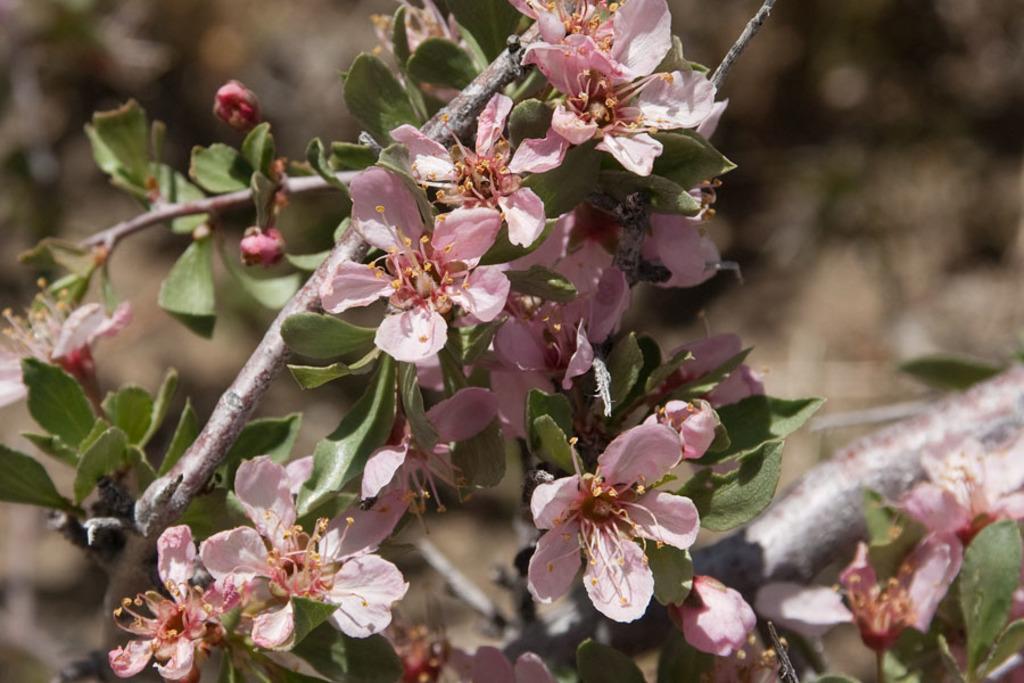Please provide a concise description of this image. In this image there is plant with flowers. 